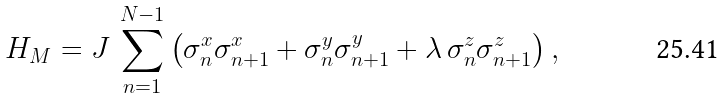Convert formula to latex. <formula><loc_0><loc_0><loc_500><loc_500>H _ { M } = J \, \sum _ { n = 1 } ^ { N - 1 } \left ( \sigma _ { n } ^ { x } \sigma _ { n + 1 } ^ { x } + \sigma _ { n } ^ { y } \sigma _ { n + 1 } ^ { y } + \lambda \, \sigma _ { n } ^ { z } \sigma _ { n + 1 } ^ { z } \right ) ,</formula> 